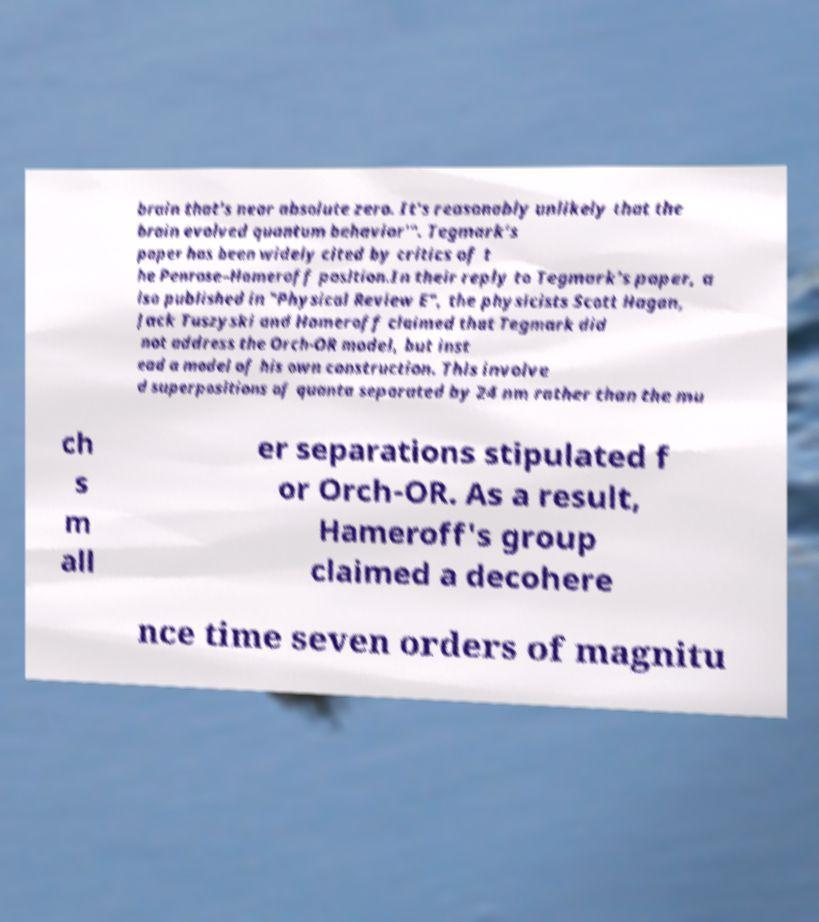Can you accurately transcribe the text from the provided image for me? brain that's near absolute zero. It's reasonably unlikely that the brain evolved quantum behavior'". Tegmark's paper has been widely cited by critics of t he Penrose–Hameroff position.In their reply to Tegmark's paper, a lso published in "Physical Review E", the physicists Scott Hagan, Jack Tuszyski and Hameroff claimed that Tegmark did not address the Orch-OR model, but inst ead a model of his own construction. This involve d superpositions of quanta separated by 24 nm rather than the mu ch s m all er separations stipulated f or Orch-OR. As a result, Hameroff's group claimed a decohere nce time seven orders of magnitu 